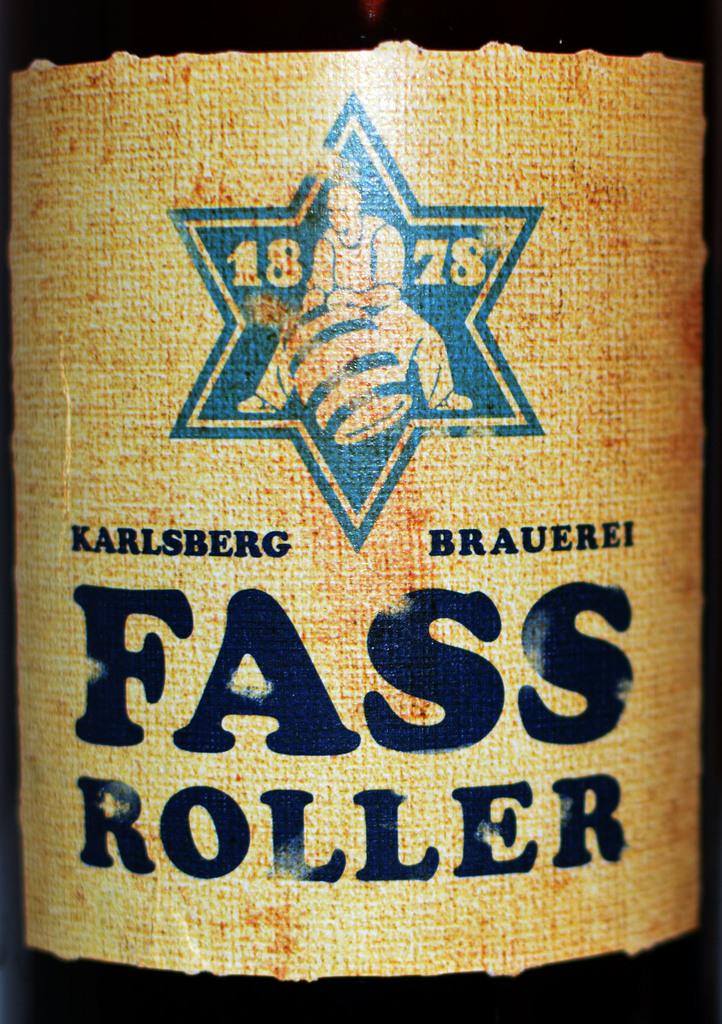What is the year on this label?
Offer a very short reply. 1878. What is the mae of this brand?
Your answer should be very brief. Karlsberg brauerei. 